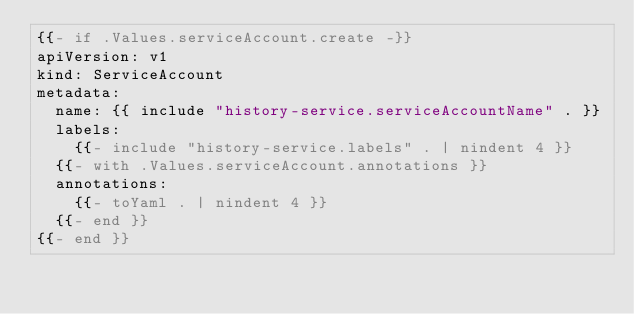Convert code to text. <code><loc_0><loc_0><loc_500><loc_500><_YAML_>{{- if .Values.serviceAccount.create -}}
apiVersion: v1
kind: ServiceAccount
metadata:
  name: {{ include "history-service.serviceAccountName" . }}
  labels:
    {{- include "history-service.labels" . | nindent 4 }}
  {{- with .Values.serviceAccount.annotations }}
  annotations:
    {{- toYaml . | nindent 4 }}
  {{- end }}
{{- end }}
</code> 